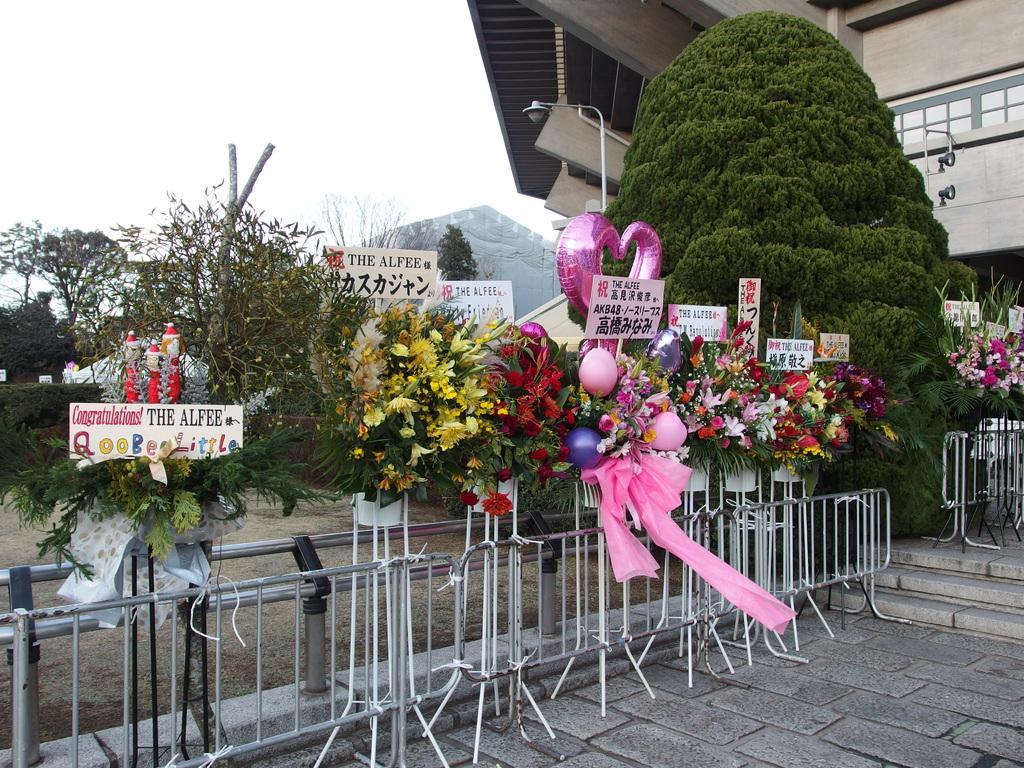In one or two sentences, can you explain what this image depicts? In this image there are metal stands in which there are flower bouquets and balloons in the middle. In the background there is a building. In front of the building there is a tree. In the background there are placards in the flower bouquets. On the right side there are steps. There are light poles in the middle. On the left side there are trees. 